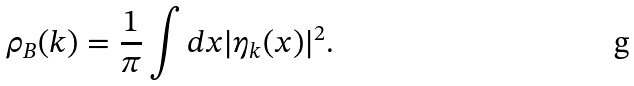<formula> <loc_0><loc_0><loc_500><loc_500>\rho _ { B } ( k ) = \frac { 1 } { \pi } \int d x | \eta _ { k } ( x ) | ^ { 2 } .</formula> 